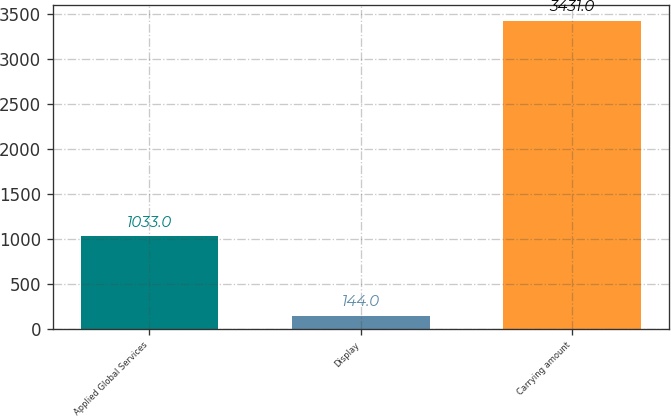Convert chart. <chart><loc_0><loc_0><loc_500><loc_500><bar_chart><fcel>Applied Global Services<fcel>Display<fcel>Carrying amount<nl><fcel>1033<fcel>144<fcel>3431<nl></chart> 